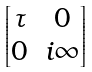Convert formula to latex. <formula><loc_0><loc_0><loc_500><loc_500>\begin{bmatrix} \tau & 0 \\ 0 & i \infty \end{bmatrix}</formula> 